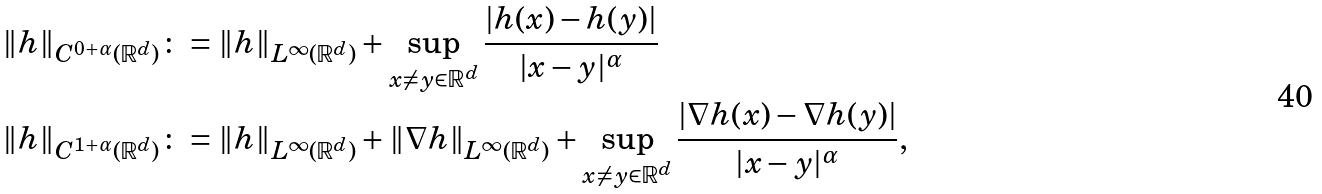<formula> <loc_0><loc_0><loc_500><loc_500>& \| h \| _ { C ^ { 0 + \alpha } ( \mathbb { R } ^ { d } ) } \colon = \| h \| _ { L ^ { \infty } ( \mathbb { R } ^ { d } ) } + \sup _ { x \neq y \in \mathbb { R } ^ { d } } \frac { | h ( x ) - h ( y ) | } { | x - y | ^ { \alpha } } \\ & \| h \| _ { C ^ { 1 + \alpha } ( \mathbb { R } ^ { d } ) } \colon = \| h \| _ { L ^ { \infty } ( \mathbb { R } ^ { d } ) } + \| \nabla h \| _ { L ^ { \infty } ( \mathbb { R } ^ { d } ) } + \sup _ { x \neq y \in \mathbb { R } ^ { d } } \frac { | \nabla h ( x ) - \nabla h ( y ) | } { | x - y | ^ { \alpha } } ,</formula> 